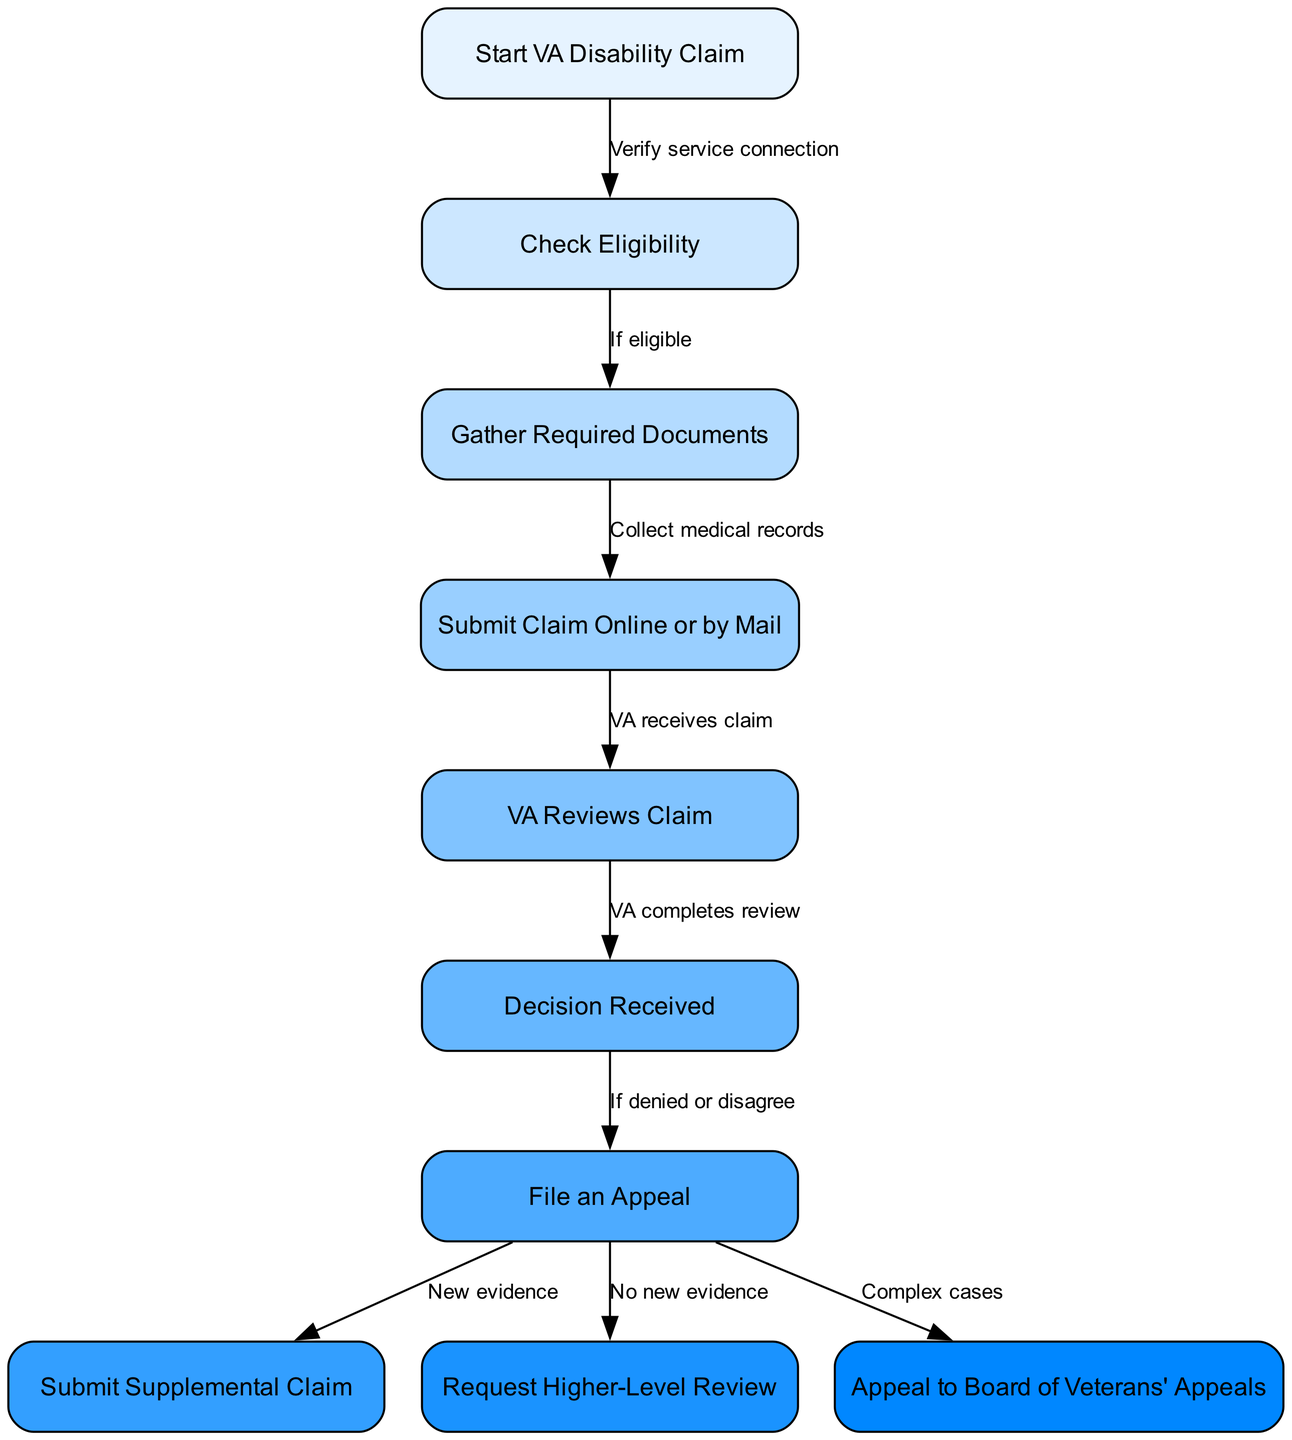What is the first step in the VA disability claim process? The first step in the diagram is represented by the node labeled "Start VA Disability Claim," which is the initial action in the process.
Answer: Start VA Disability Claim How many nodes are in the diagram? By counting each distinct node in the diagram, there are a total of 10 nodes representing different steps in the process.
Answer: 10 What does the node "Check Eligibility" lead to if eligible? From the diagram, the "Check Eligibility" node directly leads to the "Gather Required Documents" node, indicating that if a veteran is deemed eligible, the next action is to gather documentation.
Answer: Gather Required Documents What happens after the "VA Reviews Claim"? After this node, the process leads to the next step, which is "Decision Received," as the review must be completed before the decision is made.
Answer: Decision Received What action should a veteran take if the decision is denied? According to the diagram, if the decision received is a denial or the veteran disagrees with it, they should follow the "File an Appeal" route next.
Answer: File an Appeal If a claim is appealed, what are the two possible pathways? The "File an Appeal" node splits into three outcomes: if there's new evidence, the veteran can submit a supplemental claim; if there’s no new evidence, a higher-level review can be requested; if it’s a complex case, the appeal can be taken to the Board of Veterans' Appeals.
Answer: Submit Supplemental Claim or Request Higher-Level Review or Appeal to Board of Veterans' Appeals What does the edge between "Gather Required Documents" and "Submit Claim Online or by Mail" signify? The edge indicates that gathering required documents, including medical records, is a prerequisite that must be completed before proceeding to submit the claim, showing a clear relationship between these two nodes.
Answer: Collect medical records What should a veteran do if they have new evidence after filing an appeal? The diagram shows that if a veteran has new evidence after filing an appeal, they should move on to "Submit Supplemental Claim" to incorporate that evidence into their case.
Answer: Submit Supplemental Claim How many edges are present in the diagram? By counting the connections between nodes, the diagram has a total of 9 edges, representing the pathways between different steps of the claim process.
Answer: 9 